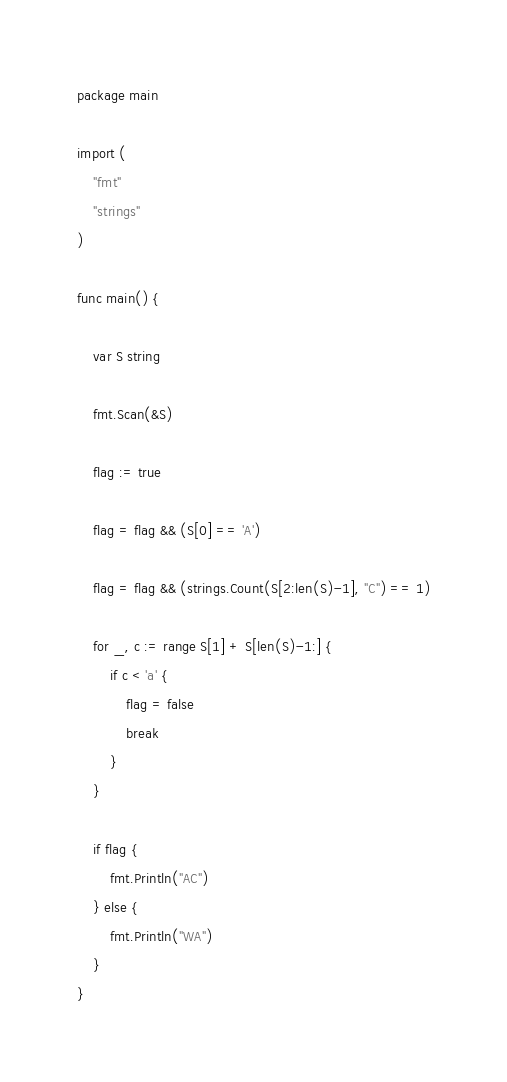<code> <loc_0><loc_0><loc_500><loc_500><_Go_>package main

import (
	"fmt"
	"strings"
)

func main() {

	var S string

	fmt.Scan(&S)

	flag := true

	flag = flag && (S[0] == 'A')

	flag = flag && (strings.Count(S[2:len(S)-1], "C") == 1)

	for _, c := range S[1] + S[len(S)-1:] {
		if c < 'a' {
			flag = false
			break
		}
	}

	if flag {
		fmt.Println("AC")
	} else {
		fmt.Println("WA")
	}
}
</code> 